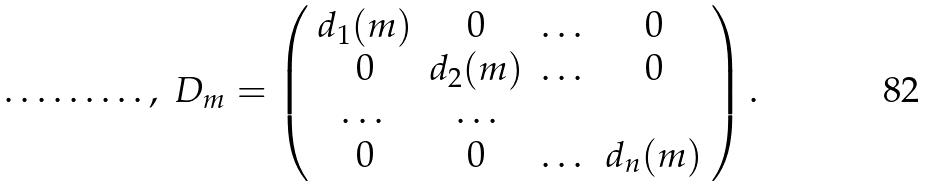Convert formula to latex. <formula><loc_0><loc_0><loc_500><loc_500>\dots \dots \dots , \ D _ { m } = \left ( \begin{array} { c c c c c c c c } d _ { 1 } ( m ) & 0 & \dots & 0 \\ 0 & d _ { 2 } ( m ) & \dots & 0 \\ \dots & \dots \\ 0 & 0 & \dots & d _ { n } ( m ) \end{array} \right ) .</formula> 